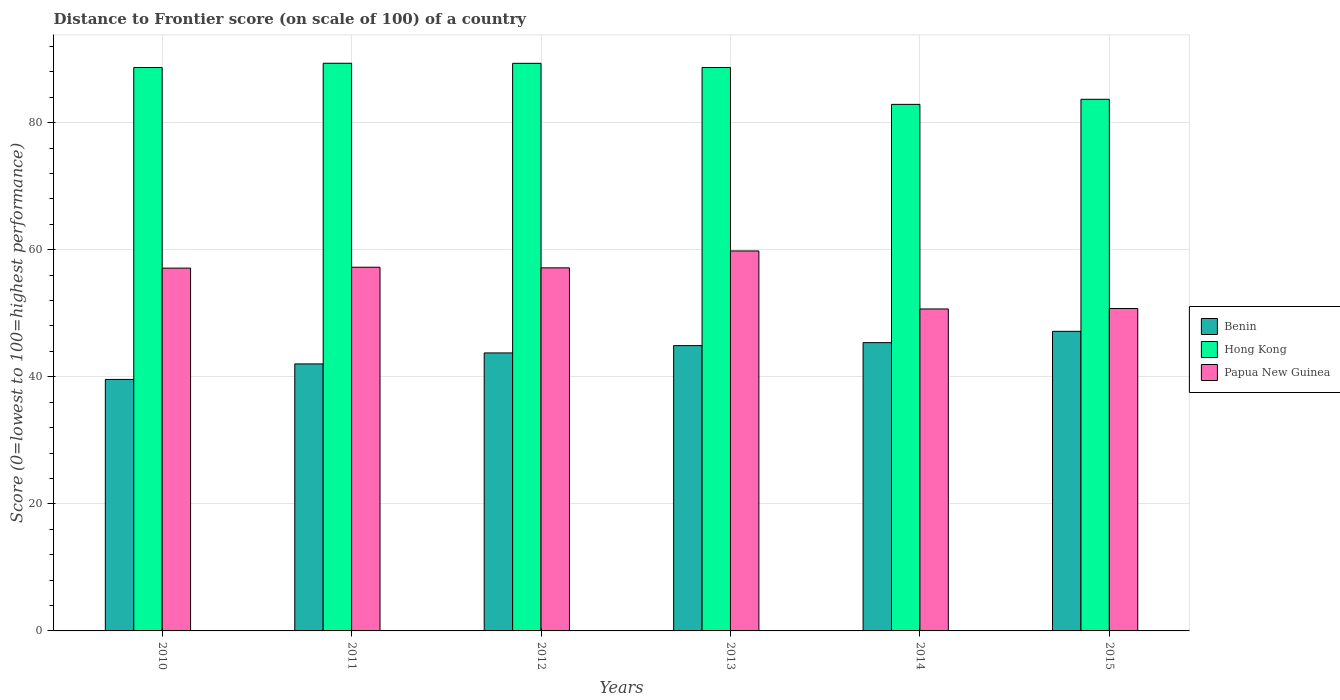How many different coloured bars are there?
Give a very brief answer. 3. How many groups of bars are there?
Ensure brevity in your answer.  6. Are the number of bars per tick equal to the number of legend labels?
Your response must be concise. Yes. How many bars are there on the 5th tick from the left?
Your response must be concise. 3. In how many cases, is the number of bars for a given year not equal to the number of legend labels?
Your answer should be compact. 0. What is the distance to frontier score of in Benin in 2012?
Make the answer very short. 43.75. Across all years, what is the maximum distance to frontier score of in Papua New Guinea?
Offer a terse response. 59.8. Across all years, what is the minimum distance to frontier score of in Papua New Guinea?
Offer a terse response. 50.67. In which year was the distance to frontier score of in Benin maximum?
Offer a very short reply. 2015. In which year was the distance to frontier score of in Papua New Guinea minimum?
Your response must be concise. 2014. What is the total distance to frontier score of in Benin in the graph?
Your response must be concise. 262.77. What is the difference between the distance to frontier score of in Papua New Guinea in 2011 and that in 2014?
Make the answer very short. 6.57. What is the difference between the distance to frontier score of in Hong Kong in 2015 and the distance to frontier score of in Benin in 2013?
Make the answer very short. 38.77. What is the average distance to frontier score of in Papua New Guinea per year?
Keep it short and to the point. 55.45. In the year 2012, what is the difference between the distance to frontier score of in Hong Kong and distance to frontier score of in Papua New Guinea?
Provide a succinct answer. 32.19. In how many years, is the distance to frontier score of in Papua New Guinea greater than 72?
Offer a terse response. 0. What is the ratio of the distance to frontier score of in Benin in 2012 to that in 2013?
Provide a short and direct response. 0.97. What is the difference between the highest and the second highest distance to frontier score of in Papua New Guinea?
Ensure brevity in your answer.  2.56. What is the difference between the highest and the lowest distance to frontier score of in Hong Kong?
Provide a succinct answer. 6.47. What does the 1st bar from the left in 2011 represents?
Provide a succinct answer. Benin. What does the 1st bar from the right in 2010 represents?
Give a very brief answer. Papua New Guinea. How many bars are there?
Your answer should be compact. 18. What is the difference between two consecutive major ticks on the Y-axis?
Your answer should be very brief. 20. Does the graph contain grids?
Provide a short and direct response. Yes. Where does the legend appear in the graph?
Give a very brief answer. Center right. How are the legend labels stacked?
Give a very brief answer. Vertical. What is the title of the graph?
Your answer should be compact. Distance to Frontier score (on scale of 100) of a country. What is the label or title of the Y-axis?
Provide a succinct answer. Score (0=lowest to 100=highest performance). What is the Score (0=lowest to 100=highest performance) in Benin in 2010?
Ensure brevity in your answer.  39.58. What is the Score (0=lowest to 100=highest performance) of Hong Kong in 2010?
Give a very brief answer. 88.67. What is the Score (0=lowest to 100=highest performance) in Papua New Guinea in 2010?
Keep it short and to the point. 57.1. What is the Score (0=lowest to 100=highest performance) in Benin in 2011?
Your response must be concise. 42.02. What is the Score (0=lowest to 100=highest performance) in Hong Kong in 2011?
Your answer should be compact. 89.34. What is the Score (0=lowest to 100=highest performance) of Papua New Guinea in 2011?
Give a very brief answer. 57.24. What is the Score (0=lowest to 100=highest performance) of Benin in 2012?
Your response must be concise. 43.75. What is the Score (0=lowest to 100=highest performance) in Hong Kong in 2012?
Provide a short and direct response. 89.33. What is the Score (0=lowest to 100=highest performance) in Papua New Guinea in 2012?
Provide a short and direct response. 57.14. What is the Score (0=lowest to 100=highest performance) of Benin in 2013?
Your response must be concise. 44.9. What is the Score (0=lowest to 100=highest performance) in Hong Kong in 2013?
Provide a succinct answer. 88.67. What is the Score (0=lowest to 100=highest performance) in Papua New Guinea in 2013?
Make the answer very short. 59.8. What is the Score (0=lowest to 100=highest performance) of Benin in 2014?
Your answer should be compact. 45.37. What is the Score (0=lowest to 100=highest performance) in Hong Kong in 2014?
Ensure brevity in your answer.  82.87. What is the Score (0=lowest to 100=highest performance) in Papua New Guinea in 2014?
Your response must be concise. 50.67. What is the Score (0=lowest to 100=highest performance) of Benin in 2015?
Your response must be concise. 47.15. What is the Score (0=lowest to 100=highest performance) in Hong Kong in 2015?
Your answer should be very brief. 83.67. What is the Score (0=lowest to 100=highest performance) in Papua New Guinea in 2015?
Provide a succinct answer. 50.74. Across all years, what is the maximum Score (0=lowest to 100=highest performance) in Benin?
Your answer should be very brief. 47.15. Across all years, what is the maximum Score (0=lowest to 100=highest performance) of Hong Kong?
Make the answer very short. 89.34. Across all years, what is the maximum Score (0=lowest to 100=highest performance) in Papua New Guinea?
Provide a succinct answer. 59.8. Across all years, what is the minimum Score (0=lowest to 100=highest performance) of Benin?
Your answer should be very brief. 39.58. Across all years, what is the minimum Score (0=lowest to 100=highest performance) in Hong Kong?
Your answer should be very brief. 82.87. Across all years, what is the minimum Score (0=lowest to 100=highest performance) of Papua New Guinea?
Give a very brief answer. 50.67. What is the total Score (0=lowest to 100=highest performance) of Benin in the graph?
Ensure brevity in your answer.  262.77. What is the total Score (0=lowest to 100=highest performance) of Hong Kong in the graph?
Ensure brevity in your answer.  522.55. What is the total Score (0=lowest to 100=highest performance) in Papua New Guinea in the graph?
Ensure brevity in your answer.  332.69. What is the difference between the Score (0=lowest to 100=highest performance) in Benin in 2010 and that in 2011?
Provide a succinct answer. -2.44. What is the difference between the Score (0=lowest to 100=highest performance) of Hong Kong in 2010 and that in 2011?
Provide a succinct answer. -0.67. What is the difference between the Score (0=lowest to 100=highest performance) in Papua New Guinea in 2010 and that in 2011?
Make the answer very short. -0.14. What is the difference between the Score (0=lowest to 100=highest performance) of Benin in 2010 and that in 2012?
Provide a succinct answer. -4.17. What is the difference between the Score (0=lowest to 100=highest performance) in Hong Kong in 2010 and that in 2012?
Your answer should be compact. -0.66. What is the difference between the Score (0=lowest to 100=highest performance) in Papua New Guinea in 2010 and that in 2012?
Keep it short and to the point. -0.04. What is the difference between the Score (0=lowest to 100=highest performance) in Benin in 2010 and that in 2013?
Provide a succinct answer. -5.32. What is the difference between the Score (0=lowest to 100=highest performance) of Hong Kong in 2010 and that in 2013?
Offer a very short reply. 0. What is the difference between the Score (0=lowest to 100=highest performance) of Benin in 2010 and that in 2014?
Your answer should be compact. -5.79. What is the difference between the Score (0=lowest to 100=highest performance) in Hong Kong in 2010 and that in 2014?
Offer a terse response. 5.8. What is the difference between the Score (0=lowest to 100=highest performance) in Papua New Guinea in 2010 and that in 2014?
Make the answer very short. 6.43. What is the difference between the Score (0=lowest to 100=highest performance) of Benin in 2010 and that in 2015?
Offer a very short reply. -7.57. What is the difference between the Score (0=lowest to 100=highest performance) of Papua New Guinea in 2010 and that in 2015?
Your answer should be very brief. 6.36. What is the difference between the Score (0=lowest to 100=highest performance) in Benin in 2011 and that in 2012?
Ensure brevity in your answer.  -1.73. What is the difference between the Score (0=lowest to 100=highest performance) in Hong Kong in 2011 and that in 2012?
Provide a succinct answer. 0.01. What is the difference between the Score (0=lowest to 100=highest performance) in Benin in 2011 and that in 2013?
Keep it short and to the point. -2.88. What is the difference between the Score (0=lowest to 100=highest performance) of Hong Kong in 2011 and that in 2013?
Your answer should be compact. 0.67. What is the difference between the Score (0=lowest to 100=highest performance) in Papua New Guinea in 2011 and that in 2013?
Ensure brevity in your answer.  -2.56. What is the difference between the Score (0=lowest to 100=highest performance) of Benin in 2011 and that in 2014?
Offer a very short reply. -3.35. What is the difference between the Score (0=lowest to 100=highest performance) in Hong Kong in 2011 and that in 2014?
Ensure brevity in your answer.  6.47. What is the difference between the Score (0=lowest to 100=highest performance) in Papua New Guinea in 2011 and that in 2014?
Ensure brevity in your answer.  6.57. What is the difference between the Score (0=lowest to 100=highest performance) of Benin in 2011 and that in 2015?
Offer a terse response. -5.13. What is the difference between the Score (0=lowest to 100=highest performance) in Hong Kong in 2011 and that in 2015?
Your answer should be very brief. 5.67. What is the difference between the Score (0=lowest to 100=highest performance) in Benin in 2012 and that in 2013?
Keep it short and to the point. -1.15. What is the difference between the Score (0=lowest to 100=highest performance) in Hong Kong in 2012 and that in 2013?
Give a very brief answer. 0.66. What is the difference between the Score (0=lowest to 100=highest performance) in Papua New Guinea in 2012 and that in 2013?
Offer a terse response. -2.66. What is the difference between the Score (0=lowest to 100=highest performance) in Benin in 2012 and that in 2014?
Provide a succinct answer. -1.62. What is the difference between the Score (0=lowest to 100=highest performance) in Hong Kong in 2012 and that in 2014?
Ensure brevity in your answer.  6.46. What is the difference between the Score (0=lowest to 100=highest performance) of Papua New Guinea in 2012 and that in 2014?
Keep it short and to the point. 6.47. What is the difference between the Score (0=lowest to 100=highest performance) of Benin in 2012 and that in 2015?
Ensure brevity in your answer.  -3.4. What is the difference between the Score (0=lowest to 100=highest performance) of Hong Kong in 2012 and that in 2015?
Your answer should be very brief. 5.66. What is the difference between the Score (0=lowest to 100=highest performance) in Benin in 2013 and that in 2014?
Give a very brief answer. -0.47. What is the difference between the Score (0=lowest to 100=highest performance) of Hong Kong in 2013 and that in 2014?
Ensure brevity in your answer.  5.8. What is the difference between the Score (0=lowest to 100=highest performance) of Papua New Guinea in 2013 and that in 2014?
Provide a succinct answer. 9.13. What is the difference between the Score (0=lowest to 100=highest performance) of Benin in 2013 and that in 2015?
Offer a terse response. -2.25. What is the difference between the Score (0=lowest to 100=highest performance) in Hong Kong in 2013 and that in 2015?
Your response must be concise. 5. What is the difference between the Score (0=lowest to 100=highest performance) of Papua New Guinea in 2013 and that in 2015?
Your response must be concise. 9.06. What is the difference between the Score (0=lowest to 100=highest performance) of Benin in 2014 and that in 2015?
Give a very brief answer. -1.78. What is the difference between the Score (0=lowest to 100=highest performance) in Hong Kong in 2014 and that in 2015?
Your answer should be very brief. -0.8. What is the difference between the Score (0=lowest to 100=highest performance) in Papua New Guinea in 2014 and that in 2015?
Offer a very short reply. -0.07. What is the difference between the Score (0=lowest to 100=highest performance) of Benin in 2010 and the Score (0=lowest to 100=highest performance) of Hong Kong in 2011?
Provide a succinct answer. -49.76. What is the difference between the Score (0=lowest to 100=highest performance) in Benin in 2010 and the Score (0=lowest to 100=highest performance) in Papua New Guinea in 2011?
Your answer should be very brief. -17.66. What is the difference between the Score (0=lowest to 100=highest performance) in Hong Kong in 2010 and the Score (0=lowest to 100=highest performance) in Papua New Guinea in 2011?
Your answer should be compact. 31.43. What is the difference between the Score (0=lowest to 100=highest performance) of Benin in 2010 and the Score (0=lowest to 100=highest performance) of Hong Kong in 2012?
Your answer should be compact. -49.75. What is the difference between the Score (0=lowest to 100=highest performance) of Benin in 2010 and the Score (0=lowest to 100=highest performance) of Papua New Guinea in 2012?
Provide a short and direct response. -17.56. What is the difference between the Score (0=lowest to 100=highest performance) of Hong Kong in 2010 and the Score (0=lowest to 100=highest performance) of Papua New Guinea in 2012?
Offer a terse response. 31.53. What is the difference between the Score (0=lowest to 100=highest performance) of Benin in 2010 and the Score (0=lowest to 100=highest performance) of Hong Kong in 2013?
Ensure brevity in your answer.  -49.09. What is the difference between the Score (0=lowest to 100=highest performance) in Benin in 2010 and the Score (0=lowest to 100=highest performance) in Papua New Guinea in 2013?
Give a very brief answer. -20.22. What is the difference between the Score (0=lowest to 100=highest performance) of Hong Kong in 2010 and the Score (0=lowest to 100=highest performance) of Papua New Guinea in 2013?
Give a very brief answer. 28.87. What is the difference between the Score (0=lowest to 100=highest performance) of Benin in 2010 and the Score (0=lowest to 100=highest performance) of Hong Kong in 2014?
Keep it short and to the point. -43.29. What is the difference between the Score (0=lowest to 100=highest performance) of Benin in 2010 and the Score (0=lowest to 100=highest performance) of Papua New Guinea in 2014?
Provide a succinct answer. -11.09. What is the difference between the Score (0=lowest to 100=highest performance) of Hong Kong in 2010 and the Score (0=lowest to 100=highest performance) of Papua New Guinea in 2014?
Give a very brief answer. 38. What is the difference between the Score (0=lowest to 100=highest performance) in Benin in 2010 and the Score (0=lowest to 100=highest performance) in Hong Kong in 2015?
Make the answer very short. -44.09. What is the difference between the Score (0=lowest to 100=highest performance) in Benin in 2010 and the Score (0=lowest to 100=highest performance) in Papua New Guinea in 2015?
Keep it short and to the point. -11.16. What is the difference between the Score (0=lowest to 100=highest performance) of Hong Kong in 2010 and the Score (0=lowest to 100=highest performance) of Papua New Guinea in 2015?
Provide a succinct answer. 37.93. What is the difference between the Score (0=lowest to 100=highest performance) in Benin in 2011 and the Score (0=lowest to 100=highest performance) in Hong Kong in 2012?
Ensure brevity in your answer.  -47.31. What is the difference between the Score (0=lowest to 100=highest performance) in Benin in 2011 and the Score (0=lowest to 100=highest performance) in Papua New Guinea in 2012?
Your response must be concise. -15.12. What is the difference between the Score (0=lowest to 100=highest performance) in Hong Kong in 2011 and the Score (0=lowest to 100=highest performance) in Papua New Guinea in 2012?
Make the answer very short. 32.2. What is the difference between the Score (0=lowest to 100=highest performance) of Benin in 2011 and the Score (0=lowest to 100=highest performance) of Hong Kong in 2013?
Your response must be concise. -46.65. What is the difference between the Score (0=lowest to 100=highest performance) of Benin in 2011 and the Score (0=lowest to 100=highest performance) of Papua New Guinea in 2013?
Your answer should be compact. -17.78. What is the difference between the Score (0=lowest to 100=highest performance) of Hong Kong in 2011 and the Score (0=lowest to 100=highest performance) of Papua New Guinea in 2013?
Ensure brevity in your answer.  29.54. What is the difference between the Score (0=lowest to 100=highest performance) of Benin in 2011 and the Score (0=lowest to 100=highest performance) of Hong Kong in 2014?
Offer a very short reply. -40.85. What is the difference between the Score (0=lowest to 100=highest performance) of Benin in 2011 and the Score (0=lowest to 100=highest performance) of Papua New Guinea in 2014?
Your answer should be very brief. -8.65. What is the difference between the Score (0=lowest to 100=highest performance) in Hong Kong in 2011 and the Score (0=lowest to 100=highest performance) in Papua New Guinea in 2014?
Provide a succinct answer. 38.67. What is the difference between the Score (0=lowest to 100=highest performance) in Benin in 2011 and the Score (0=lowest to 100=highest performance) in Hong Kong in 2015?
Your answer should be compact. -41.65. What is the difference between the Score (0=lowest to 100=highest performance) in Benin in 2011 and the Score (0=lowest to 100=highest performance) in Papua New Guinea in 2015?
Offer a very short reply. -8.72. What is the difference between the Score (0=lowest to 100=highest performance) in Hong Kong in 2011 and the Score (0=lowest to 100=highest performance) in Papua New Guinea in 2015?
Make the answer very short. 38.6. What is the difference between the Score (0=lowest to 100=highest performance) in Benin in 2012 and the Score (0=lowest to 100=highest performance) in Hong Kong in 2013?
Give a very brief answer. -44.92. What is the difference between the Score (0=lowest to 100=highest performance) of Benin in 2012 and the Score (0=lowest to 100=highest performance) of Papua New Guinea in 2013?
Your answer should be very brief. -16.05. What is the difference between the Score (0=lowest to 100=highest performance) of Hong Kong in 2012 and the Score (0=lowest to 100=highest performance) of Papua New Guinea in 2013?
Give a very brief answer. 29.53. What is the difference between the Score (0=lowest to 100=highest performance) of Benin in 2012 and the Score (0=lowest to 100=highest performance) of Hong Kong in 2014?
Make the answer very short. -39.12. What is the difference between the Score (0=lowest to 100=highest performance) in Benin in 2012 and the Score (0=lowest to 100=highest performance) in Papua New Guinea in 2014?
Provide a short and direct response. -6.92. What is the difference between the Score (0=lowest to 100=highest performance) of Hong Kong in 2012 and the Score (0=lowest to 100=highest performance) of Papua New Guinea in 2014?
Give a very brief answer. 38.66. What is the difference between the Score (0=lowest to 100=highest performance) of Benin in 2012 and the Score (0=lowest to 100=highest performance) of Hong Kong in 2015?
Provide a short and direct response. -39.92. What is the difference between the Score (0=lowest to 100=highest performance) in Benin in 2012 and the Score (0=lowest to 100=highest performance) in Papua New Guinea in 2015?
Offer a terse response. -6.99. What is the difference between the Score (0=lowest to 100=highest performance) in Hong Kong in 2012 and the Score (0=lowest to 100=highest performance) in Papua New Guinea in 2015?
Offer a very short reply. 38.59. What is the difference between the Score (0=lowest to 100=highest performance) of Benin in 2013 and the Score (0=lowest to 100=highest performance) of Hong Kong in 2014?
Your answer should be very brief. -37.97. What is the difference between the Score (0=lowest to 100=highest performance) in Benin in 2013 and the Score (0=lowest to 100=highest performance) in Papua New Guinea in 2014?
Your answer should be very brief. -5.77. What is the difference between the Score (0=lowest to 100=highest performance) in Hong Kong in 2013 and the Score (0=lowest to 100=highest performance) in Papua New Guinea in 2014?
Offer a very short reply. 38. What is the difference between the Score (0=lowest to 100=highest performance) of Benin in 2013 and the Score (0=lowest to 100=highest performance) of Hong Kong in 2015?
Make the answer very short. -38.77. What is the difference between the Score (0=lowest to 100=highest performance) in Benin in 2013 and the Score (0=lowest to 100=highest performance) in Papua New Guinea in 2015?
Give a very brief answer. -5.84. What is the difference between the Score (0=lowest to 100=highest performance) of Hong Kong in 2013 and the Score (0=lowest to 100=highest performance) of Papua New Guinea in 2015?
Provide a short and direct response. 37.93. What is the difference between the Score (0=lowest to 100=highest performance) in Benin in 2014 and the Score (0=lowest to 100=highest performance) in Hong Kong in 2015?
Provide a succinct answer. -38.3. What is the difference between the Score (0=lowest to 100=highest performance) in Benin in 2014 and the Score (0=lowest to 100=highest performance) in Papua New Guinea in 2015?
Your response must be concise. -5.37. What is the difference between the Score (0=lowest to 100=highest performance) of Hong Kong in 2014 and the Score (0=lowest to 100=highest performance) of Papua New Guinea in 2015?
Provide a succinct answer. 32.13. What is the average Score (0=lowest to 100=highest performance) in Benin per year?
Keep it short and to the point. 43.8. What is the average Score (0=lowest to 100=highest performance) of Hong Kong per year?
Provide a short and direct response. 87.09. What is the average Score (0=lowest to 100=highest performance) in Papua New Guinea per year?
Offer a very short reply. 55.45. In the year 2010, what is the difference between the Score (0=lowest to 100=highest performance) in Benin and Score (0=lowest to 100=highest performance) in Hong Kong?
Your answer should be very brief. -49.09. In the year 2010, what is the difference between the Score (0=lowest to 100=highest performance) in Benin and Score (0=lowest to 100=highest performance) in Papua New Guinea?
Keep it short and to the point. -17.52. In the year 2010, what is the difference between the Score (0=lowest to 100=highest performance) of Hong Kong and Score (0=lowest to 100=highest performance) of Papua New Guinea?
Keep it short and to the point. 31.57. In the year 2011, what is the difference between the Score (0=lowest to 100=highest performance) in Benin and Score (0=lowest to 100=highest performance) in Hong Kong?
Give a very brief answer. -47.32. In the year 2011, what is the difference between the Score (0=lowest to 100=highest performance) in Benin and Score (0=lowest to 100=highest performance) in Papua New Guinea?
Keep it short and to the point. -15.22. In the year 2011, what is the difference between the Score (0=lowest to 100=highest performance) in Hong Kong and Score (0=lowest to 100=highest performance) in Papua New Guinea?
Your response must be concise. 32.1. In the year 2012, what is the difference between the Score (0=lowest to 100=highest performance) in Benin and Score (0=lowest to 100=highest performance) in Hong Kong?
Your answer should be very brief. -45.58. In the year 2012, what is the difference between the Score (0=lowest to 100=highest performance) in Benin and Score (0=lowest to 100=highest performance) in Papua New Guinea?
Make the answer very short. -13.39. In the year 2012, what is the difference between the Score (0=lowest to 100=highest performance) of Hong Kong and Score (0=lowest to 100=highest performance) of Papua New Guinea?
Make the answer very short. 32.19. In the year 2013, what is the difference between the Score (0=lowest to 100=highest performance) in Benin and Score (0=lowest to 100=highest performance) in Hong Kong?
Your response must be concise. -43.77. In the year 2013, what is the difference between the Score (0=lowest to 100=highest performance) in Benin and Score (0=lowest to 100=highest performance) in Papua New Guinea?
Offer a very short reply. -14.9. In the year 2013, what is the difference between the Score (0=lowest to 100=highest performance) of Hong Kong and Score (0=lowest to 100=highest performance) of Papua New Guinea?
Make the answer very short. 28.87. In the year 2014, what is the difference between the Score (0=lowest to 100=highest performance) in Benin and Score (0=lowest to 100=highest performance) in Hong Kong?
Give a very brief answer. -37.5. In the year 2014, what is the difference between the Score (0=lowest to 100=highest performance) in Hong Kong and Score (0=lowest to 100=highest performance) in Papua New Guinea?
Offer a terse response. 32.2. In the year 2015, what is the difference between the Score (0=lowest to 100=highest performance) of Benin and Score (0=lowest to 100=highest performance) of Hong Kong?
Your answer should be very brief. -36.52. In the year 2015, what is the difference between the Score (0=lowest to 100=highest performance) of Benin and Score (0=lowest to 100=highest performance) of Papua New Guinea?
Your response must be concise. -3.59. In the year 2015, what is the difference between the Score (0=lowest to 100=highest performance) of Hong Kong and Score (0=lowest to 100=highest performance) of Papua New Guinea?
Your answer should be very brief. 32.93. What is the ratio of the Score (0=lowest to 100=highest performance) of Benin in 2010 to that in 2011?
Provide a short and direct response. 0.94. What is the ratio of the Score (0=lowest to 100=highest performance) of Papua New Guinea in 2010 to that in 2011?
Make the answer very short. 1. What is the ratio of the Score (0=lowest to 100=highest performance) of Benin in 2010 to that in 2012?
Your answer should be very brief. 0.9. What is the ratio of the Score (0=lowest to 100=highest performance) in Papua New Guinea in 2010 to that in 2012?
Provide a short and direct response. 1. What is the ratio of the Score (0=lowest to 100=highest performance) of Benin in 2010 to that in 2013?
Make the answer very short. 0.88. What is the ratio of the Score (0=lowest to 100=highest performance) in Papua New Guinea in 2010 to that in 2013?
Your response must be concise. 0.95. What is the ratio of the Score (0=lowest to 100=highest performance) in Benin in 2010 to that in 2014?
Your answer should be very brief. 0.87. What is the ratio of the Score (0=lowest to 100=highest performance) of Hong Kong in 2010 to that in 2014?
Your response must be concise. 1.07. What is the ratio of the Score (0=lowest to 100=highest performance) of Papua New Guinea in 2010 to that in 2014?
Give a very brief answer. 1.13. What is the ratio of the Score (0=lowest to 100=highest performance) in Benin in 2010 to that in 2015?
Provide a succinct answer. 0.84. What is the ratio of the Score (0=lowest to 100=highest performance) in Hong Kong in 2010 to that in 2015?
Ensure brevity in your answer.  1.06. What is the ratio of the Score (0=lowest to 100=highest performance) of Papua New Guinea in 2010 to that in 2015?
Offer a terse response. 1.13. What is the ratio of the Score (0=lowest to 100=highest performance) in Benin in 2011 to that in 2012?
Offer a very short reply. 0.96. What is the ratio of the Score (0=lowest to 100=highest performance) in Benin in 2011 to that in 2013?
Your answer should be compact. 0.94. What is the ratio of the Score (0=lowest to 100=highest performance) in Hong Kong in 2011 to that in 2013?
Your answer should be compact. 1.01. What is the ratio of the Score (0=lowest to 100=highest performance) in Papua New Guinea in 2011 to that in 2013?
Give a very brief answer. 0.96. What is the ratio of the Score (0=lowest to 100=highest performance) of Benin in 2011 to that in 2014?
Your response must be concise. 0.93. What is the ratio of the Score (0=lowest to 100=highest performance) of Hong Kong in 2011 to that in 2014?
Provide a short and direct response. 1.08. What is the ratio of the Score (0=lowest to 100=highest performance) of Papua New Guinea in 2011 to that in 2014?
Your answer should be very brief. 1.13. What is the ratio of the Score (0=lowest to 100=highest performance) in Benin in 2011 to that in 2015?
Offer a terse response. 0.89. What is the ratio of the Score (0=lowest to 100=highest performance) of Hong Kong in 2011 to that in 2015?
Ensure brevity in your answer.  1.07. What is the ratio of the Score (0=lowest to 100=highest performance) of Papua New Guinea in 2011 to that in 2015?
Ensure brevity in your answer.  1.13. What is the ratio of the Score (0=lowest to 100=highest performance) in Benin in 2012 to that in 2013?
Your response must be concise. 0.97. What is the ratio of the Score (0=lowest to 100=highest performance) of Hong Kong in 2012 to that in 2013?
Ensure brevity in your answer.  1.01. What is the ratio of the Score (0=lowest to 100=highest performance) of Papua New Guinea in 2012 to that in 2013?
Ensure brevity in your answer.  0.96. What is the ratio of the Score (0=lowest to 100=highest performance) in Hong Kong in 2012 to that in 2014?
Give a very brief answer. 1.08. What is the ratio of the Score (0=lowest to 100=highest performance) in Papua New Guinea in 2012 to that in 2014?
Provide a succinct answer. 1.13. What is the ratio of the Score (0=lowest to 100=highest performance) in Benin in 2012 to that in 2015?
Provide a short and direct response. 0.93. What is the ratio of the Score (0=lowest to 100=highest performance) in Hong Kong in 2012 to that in 2015?
Keep it short and to the point. 1.07. What is the ratio of the Score (0=lowest to 100=highest performance) of Papua New Guinea in 2012 to that in 2015?
Ensure brevity in your answer.  1.13. What is the ratio of the Score (0=lowest to 100=highest performance) of Hong Kong in 2013 to that in 2014?
Make the answer very short. 1.07. What is the ratio of the Score (0=lowest to 100=highest performance) of Papua New Guinea in 2013 to that in 2014?
Provide a succinct answer. 1.18. What is the ratio of the Score (0=lowest to 100=highest performance) in Benin in 2013 to that in 2015?
Provide a succinct answer. 0.95. What is the ratio of the Score (0=lowest to 100=highest performance) of Hong Kong in 2013 to that in 2015?
Offer a very short reply. 1.06. What is the ratio of the Score (0=lowest to 100=highest performance) in Papua New Guinea in 2013 to that in 2015?
Keep it short and to the point. 1.18. What is the ratio of the Score (0=lowest to 100=highest performance) of Benin in 2014 to that in 2015?
Provide a succinct answer. 0.96. What is the ratio of the Score (0=lowest to 100=highest performance) of Papua New Guinea in 2014 to that in 2015?
Give a very brief answer. 1. What is the difference between the highest and the second highest Score (0=lowest to 100=highest performance) in Benin?
Ensure brevity in your answer.  1.78. What is the difference between the highest and the second highest Score (0=lowest to 100=highest performance) in Papua New Guinea?
Offer a terse response. 2.56. What is the difference between the highest and the lowest Score (0=lowest to 100=highest performance) of Benin?
Your answer should be compact. 7.57. What is the difference between the highest and the lowest Score (0=lowest to 100=highest performance) in Hong Kong?
Give a very brief answer. 6.47. What is the difference between the highest and the lowest Score (0=lowest to 100=highest performance) in Papua New Guinea?
Provide a short and direct response. 9.13. 